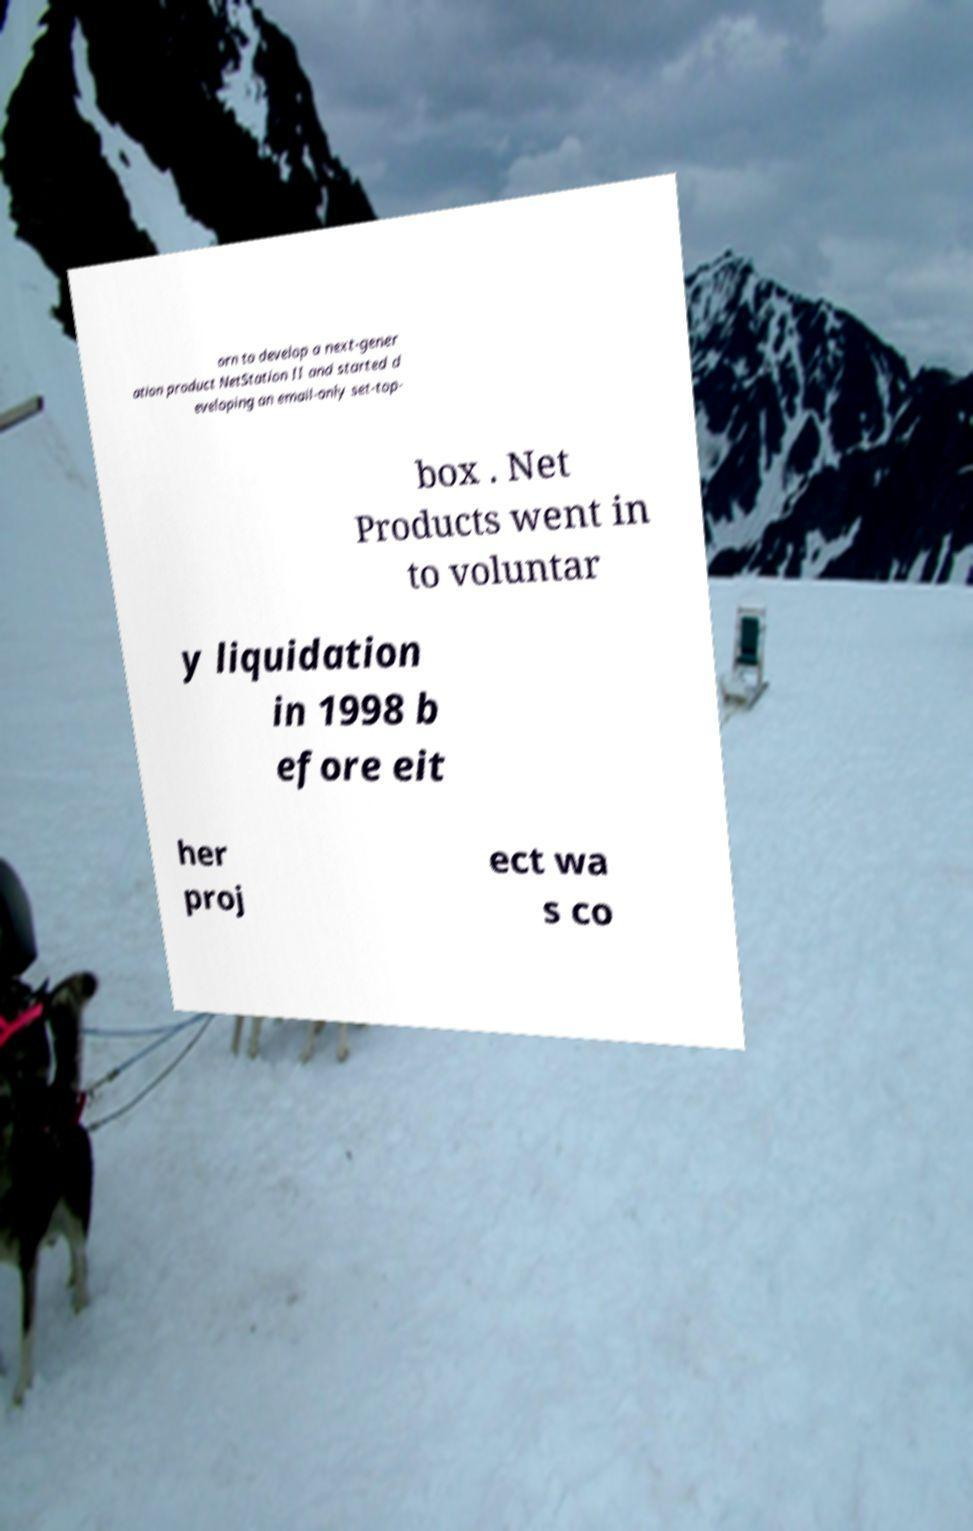I need the written content from this picture converted into text. Can you do that? orn to develop a next-gener ation product NetStation II and started d eveloping an email-only set-top- box . Net Products went in to voluntar y liquidation in 1998 b efore eit her proj ect wa s co 